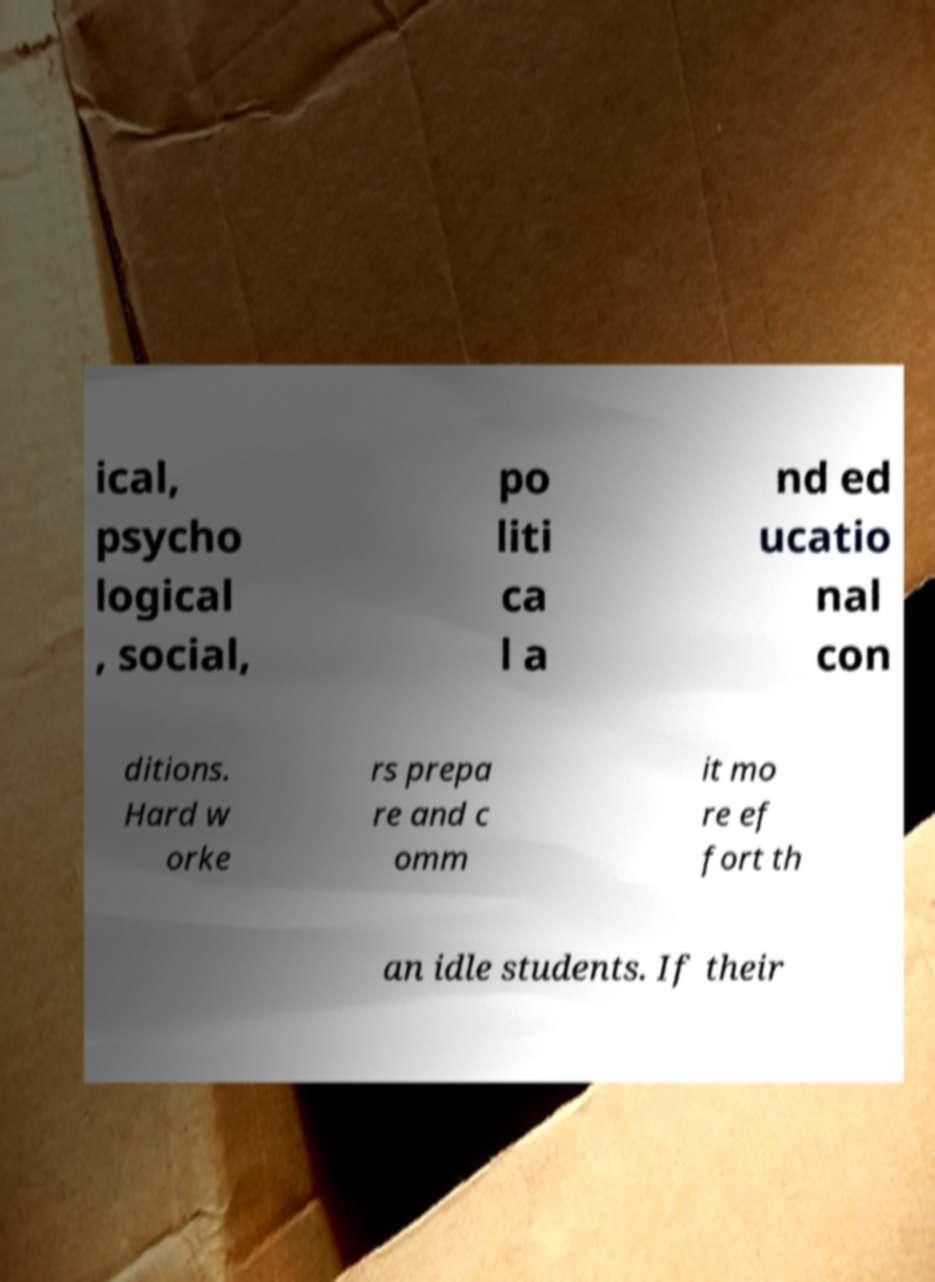Please read and relay the text visible in this image. What does it say? ical, psycho logical , social, po liti ca l a nd ed ucatio nal con ditions. Hard w orke rs prepa re and c omm it mo re ef fort th an idle students. If their 